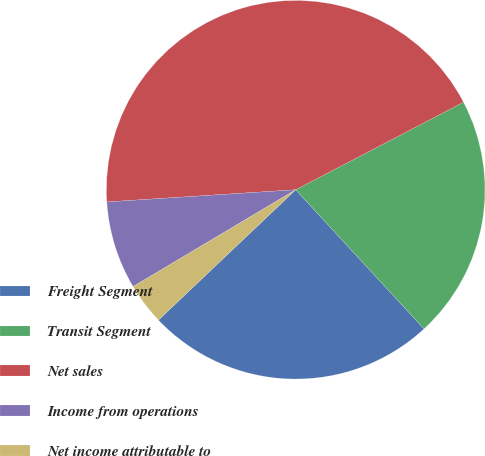Convert chart. <chart><loc_0><loc_0><loc_500><loc_500><pie_chart><fcel>Freight Segment<fcel>Transit Segment<fcel>Net sales<fcel>Income from operations<fcel>Net income attributable to<nl><fcel>24.77%<fcel>20.79%<fcel>43.37%<fcel>7.52%<fcel>3.54%<nl></chart> 